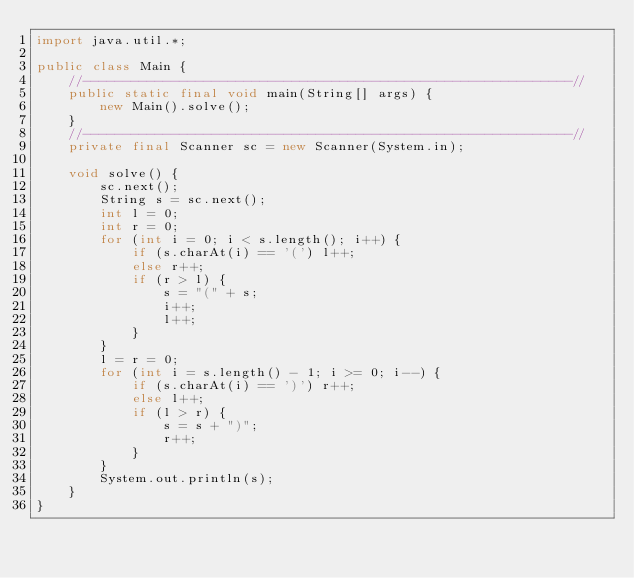Convert code to text. <code><loc_0><loc_0><loc_500><loc_500><_Java_>import java.util.*;

public class Main {
    //-------------------------------------------------------------//
    public static final void main(String[] args) {
        new Main().solve();
    }
    //-------------------------------------------------------------//
    private final Scanner sc = new Scanner(System.in);

    void solve() {
        sc.next();
        String s = sc.next();
        int l = 0;
        int r = 0;
        for (int i = 0; i < s.length(); i++) {
            if (s.charAt(i) == '(') l++;
            else r++;
            if (r > l) {
                s = "(" + s;
                i++;
                l++;
            }
        }
        l = r = 0;
        for (int i = s.length() - 1; i >= 0; i--) {
            if (s.charAt(i) == ')') r++;
            else l++;
            if (l > r) {
                s = s + ")";
                r++;
            }
        }
        System.out.println(s);
    }
}</code> 